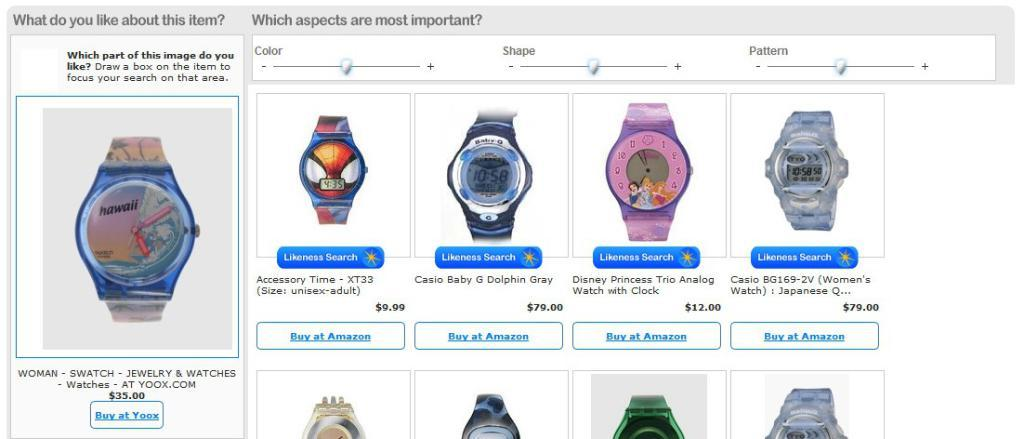<image>
Render a clear and concise summary of the photo. A screen showing several watches says "likeness search" under each watch. 